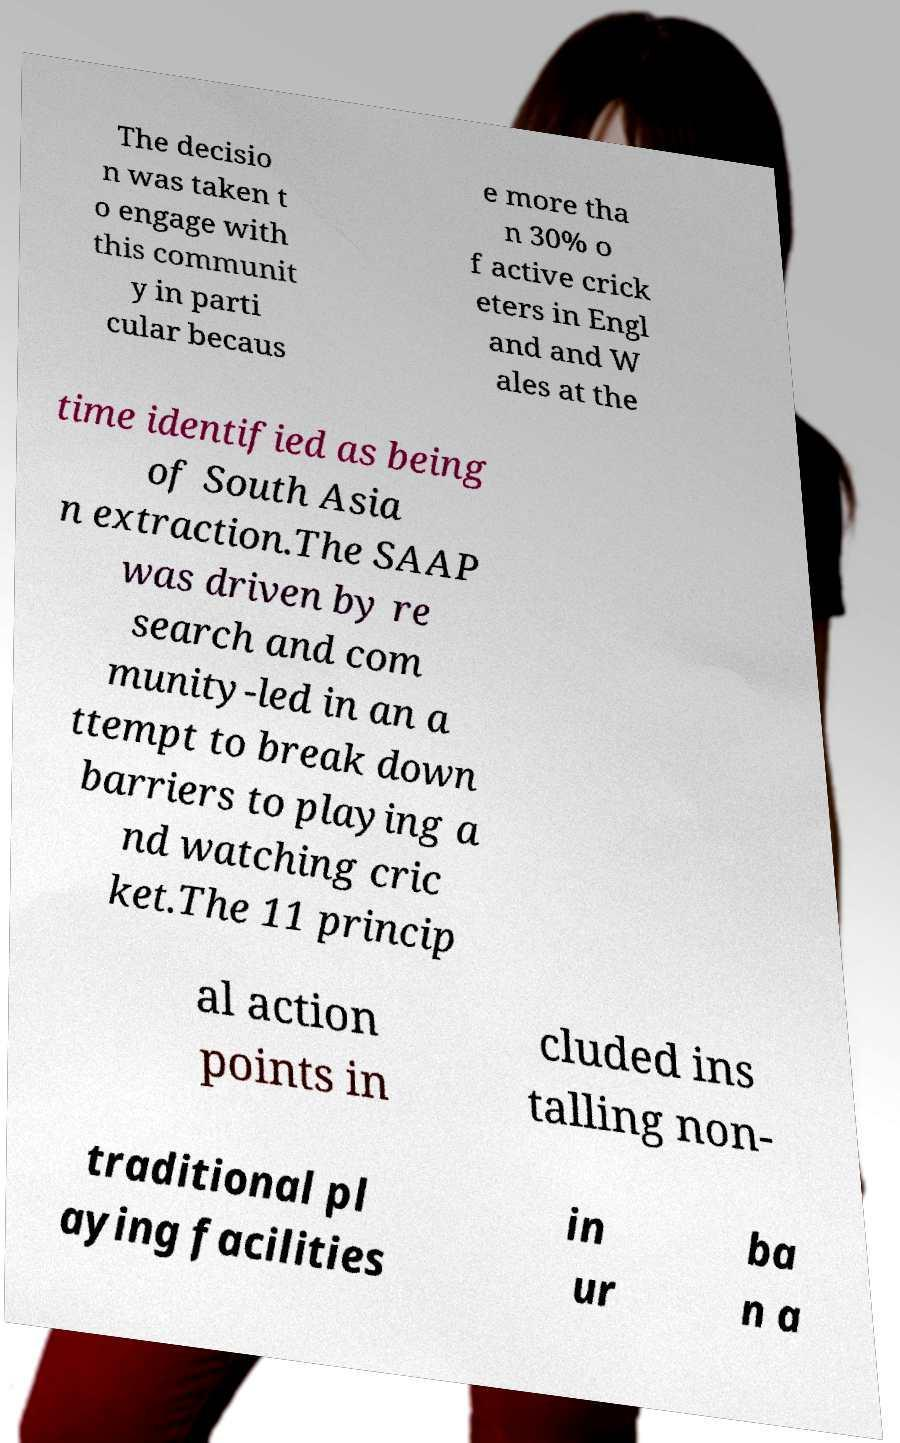For documentation purposes, I need the text within this image transcribed. Could you provide that? The decisio n was taken t o engage with this communit y in parti cular becaus e more tha n 30% o f active crick eters in Engl and and W ales at the time identified as being of South Asia n extraction.The SAAP was driven by re search and com munity-led in an a ttempt to break down barriers to playing a nd watching cric ket.The 11 princip al action points in cluded ins talling non- traditional pl aying facilities in ur ba n a 